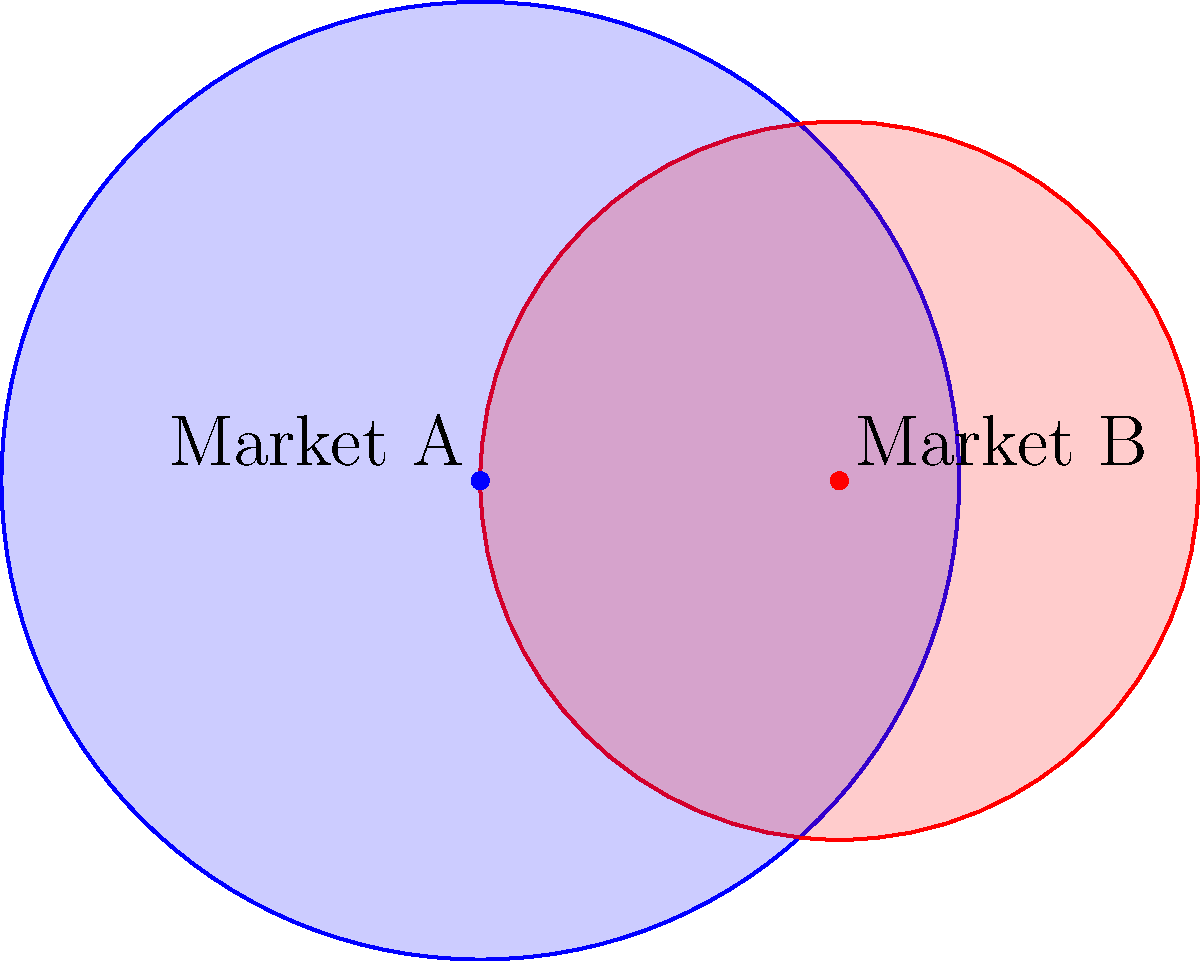As a sales representative, you're analyzing market segmentation for two products. The circles represent the target markets for Product A (blue) and Product B (red). Given that the radius of Market A is 2 units, the radius of Market B is 1.5 units, and the distance between their centers is 1.5 units, what percentage of Market B overlaps with Market A? Round your answer to the nearest whole percent. To solve this problem, we'll follow these steps:

1) First, we need to find the area of the overlapping region. This can be done using the formula for the area of intersection of two circles:

   $$A = r_1^2 \arccos(\frac{d^2 + r_1^2 - r_2^2}{2dr_1}) + r_2^2 \arccos(\frac{d^2 + r_2^2 - r_1^2}{2dr_2}) - \frac{1}{2}\sqrt{(-d+r_1+r_2)(d+r_1-r_2)(d-r_1+r_2)(d+r_1+r_2)}$$

   Where $r_1$ and $r_2$ are the radii of the circles, and $d$ is the distance between their centers.

2) Let's plug in our values:
   $r_1 = 2$ (Market A)
   $r_2 = 1.5$ (Market B)
   $d = 1.5$ (distance between centers)

3) Calculating the area of intersection:
   $$A \approx 4.3416$$ (units squared)

4) Now, we need to find the total area of Market B:
   $$A_B = \pi r_2^2 = \pi (1.5)^2 \approx 7.0686$$ (units squared)

5) The percentage of Market B that overlaps with Market A is:
   $$\text{Overlap Percentage} = \frac{\text{Area of Intersection}}{\text{Total Area of Market B}} \times 100\%$$
   $$= \frac{4.3416}{7.0686} \times 100\% \approx 61.42\%$$

6) Rounding to the nearest whole percent gives us 61%.

This overlap represents the portion of Market B that also falls within Market A, indicating potential competition or shared customer base between the two products.
Answer: 61% 